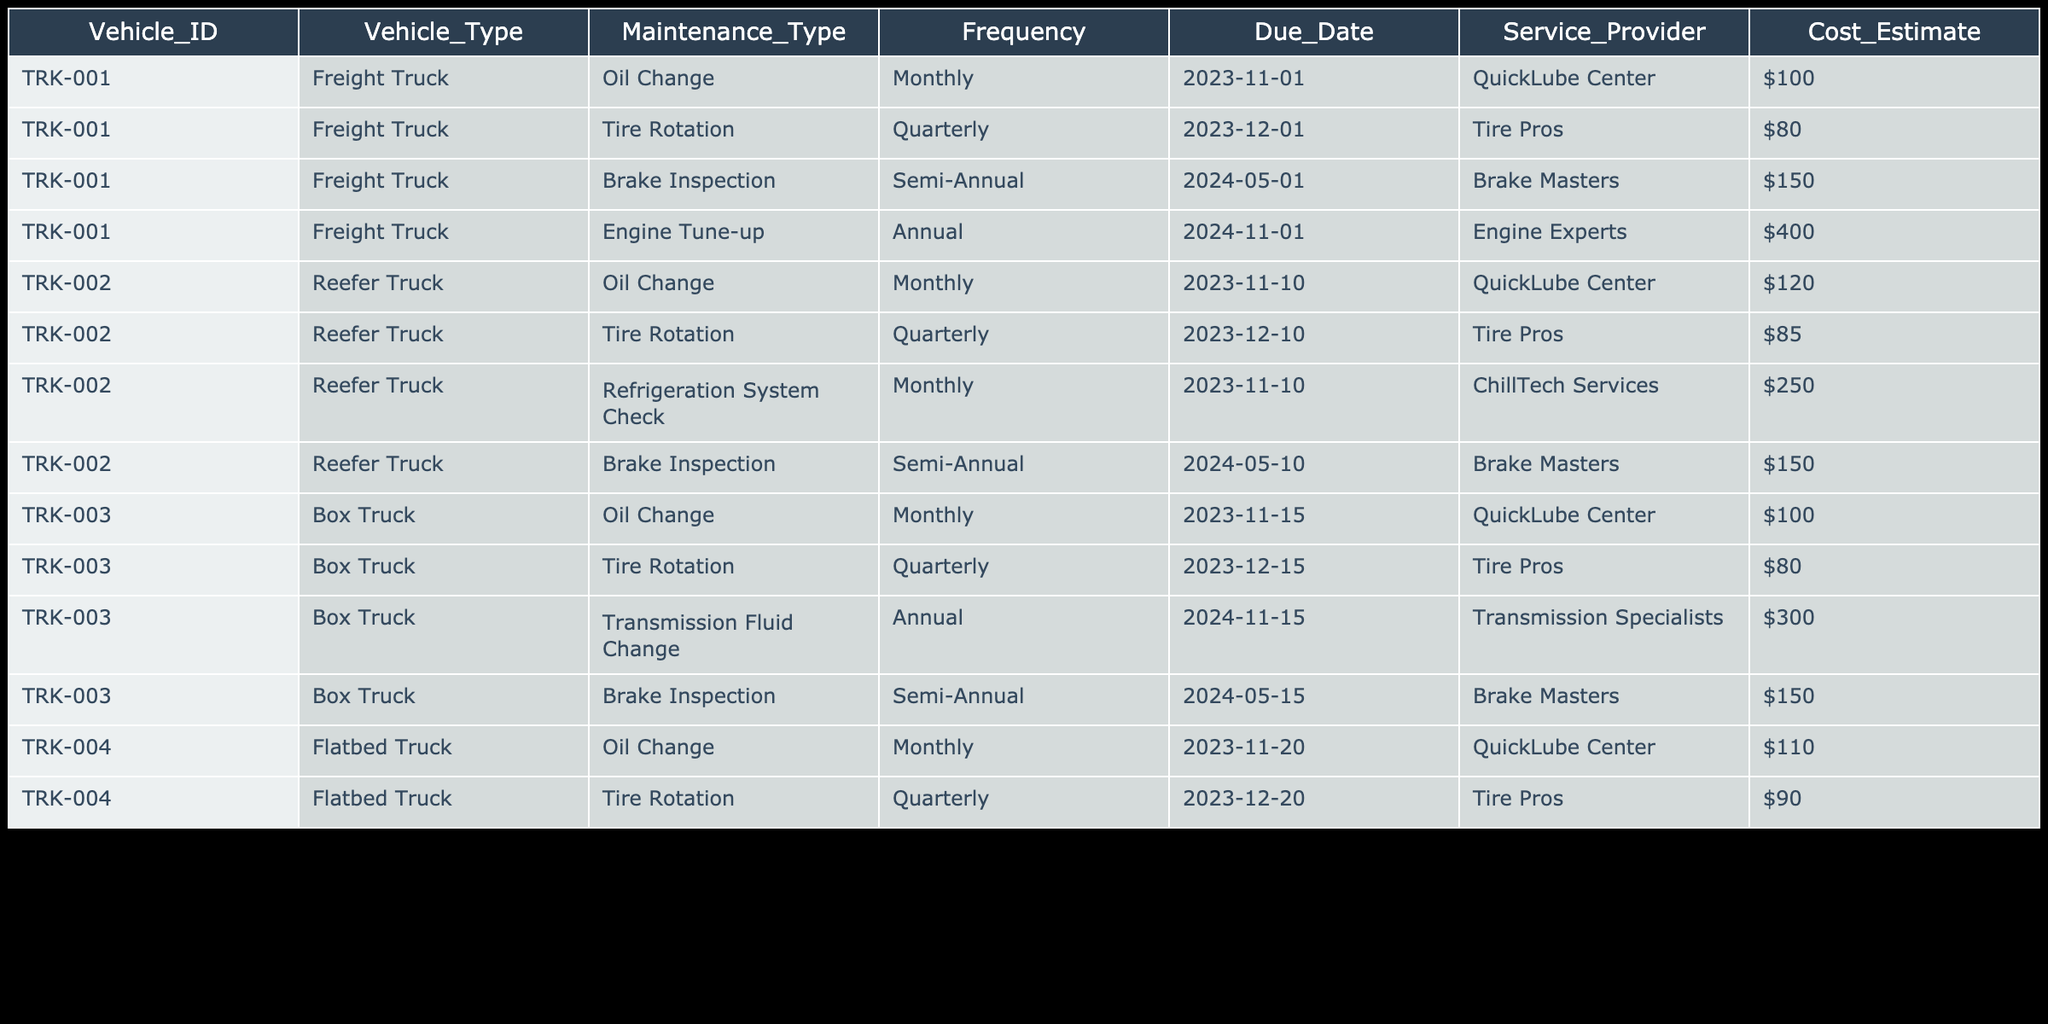What is the cost estimate for the oil change of TRK-001? Looking at the table, for TRK-001 under the Maintenance_Type column, the oil change has a cost estimate listed next to it in the Cost_Estimate column. The cost is $100.
Answer: $100 When is the next tire rotation due for TRK-002? The table shows that for TRK-002, the tire rotation is listed under the Maintenance_Type column with a due date of 2023-12-10 in the Due_Date column.
Answer: 2023-12-10 Is there a brake inspection scheduled for TRK-003 in 2024? By checking the table, TRK-003 has a brake inspection scheduled under the Maintenance_Type column with a due date of 2024-05-15 indicating that there is indeed a scheduled inspection that year.
Answer: Yes What is the total estimated cost for all maintenance on TRK-001? The maintenance types and their costs for TRK-001 are: Oil Change ($100), Tire Rotation ($80), Brake Inspection ($150), and Engine Tune-up ($400). Adding these together: 100 + 80 + 150 + 400 = 730.
Answer: $730 Is there a refrigeration system check scheduled for any truck? Looking through the table, only TRK-002 has a refrigeration system check listed under the Maintenance_Type column, with the associated due date and cost.
Answer: Yes What is the frequency of the engine tune-up for TRK-001? In the table, for TRK-001 under the frequency column, the engine tune-up is specified as an annual maintenance task.
Answer: Annual How many different vehicles have an oil change scheduled in November 2023? Checking the table, TRK-001, TRK-002, and TRK-003 all have oil changes listed with due dates in November. That's three vehicles.
Answer: 3 What is the total cost estimate for the tire rotations across all trucks? The cost estimates for tire rotations are: TRK-001 ($80), TRK-002 ($85), TRK-003 ($80), and TRK-004 ($90). Adding these amounts gives: 80 + 85 + 80 + 90 = 335.
Answer: $335 